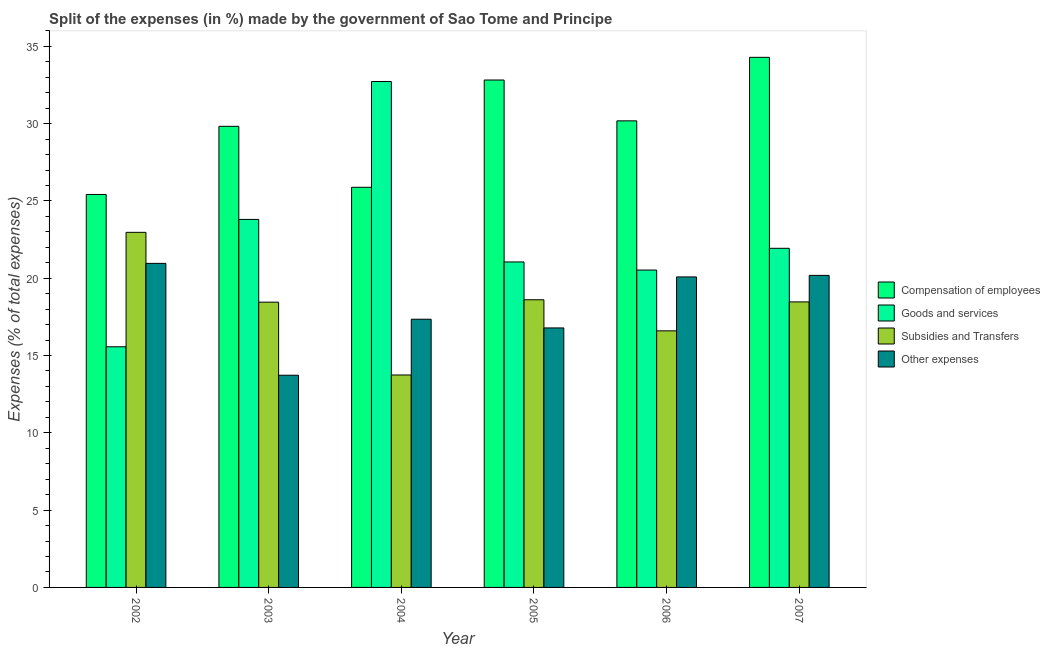How many different coloured bars are there?
Offer a terse response. 4. How many groups of bars are there?
Your answer should be very brief. 6. How many bars are there on the 2nd tick from the left?
Your answer should be compact. 4. How many bars are there on the 2nd tick from the right?
Provide a short and direct response. 4. What is the percentage of amount spent on goods and services in 2003?
Offer a terse response. 23.81. Across all years, what is the maximum percentage of amount spent on goods and services?
Offer a very short reply. 32.73. Across all years, what is the minimum percentage of amount spent on compensation of employees?
Provide a succinct answer. 25.42. In which year was the percentage of amount spent on subsidies maximum?
Make the answer very short. 2002. What is the total percentage of amount spent on other expenses in the graph?
Keep it short and to the point. 109.09. What is the difference between the percentage of amount spent on subsidies in 2002 and that in 2006?
Provide a short and direct response. 6.37. What is the difference between the percentage of amount spent on other expenses in 2004 and the percentage of amount spent on subsidies in 2002?
Keep it short and to the point. -3.61. What is the average percentage of amount spent on subsidies per year?
Offer a very short reply. 18.14. What is the ratio of the percentage of amount spent on compensation of employees in 2006 to that in 2007?
Your response must be concise. 0.88. Is the percentage of amount spent on subsidies in 2003 less than that in 2004?
Offer a terse response. No. Is the difference between the percentage of amount spent on subsidies in 2003 and 2007 greater than the difference between the percentage of amount spent on other expenses in 2003 and 2007?
Your response must be concise. No. What is the difference between the highest and the second highest percentage of amount spent on goods and services?
Your answer should be very brief. 8.92. What is the difference between the highest and the lowest percentage of amount spent on other expenses?
Give a very brief answer. 7.24. Is the sum of the percentage of amount spent on goods and services in 2002 and 2004 greater than the maximum percentage of amount spent on subsidies across all years?
Your answer should be very brief. Yes. Is it the case that in every year, the sum of the percentage of amount spent on subsidies and percentage of amount spent on goods and services is greater than the sum of percentage of amount spent on other expenses and percentage of amount spent on compensation of employees?
Give a very brief answer. No. What does the 1st bar from the left in 2004 represents?
Give a very brief answer. Compensation of employees. What does the 4th bar from the right in 2002 represents?
Your answer should be very brief. Compensation of employees. Is it the case that in every year, the sum of the percentage of amount spent on compensation of employees and percentage of amount spent on goods and services is greater than the percentage of amount spent on subsidies?
Make the answer very short. Yes. How many bars are there?
Make the answer very short. 24. How many years are there in the graph?
Provide a short and direct response. 6. What is the difference between two consecutive major ticks on the Y-axis?
Ensure brevity in your answer.  5. Are the values on the major ticks of Y-axis written in scientific E-notation?
Provide a short and direct response. No. Where does the legend appear in the graph?
Ensure brevity in your answer.  Center right. What is the title of the graph?
Give a very brief answer. Split of the expenses (in %) made by the government of Sao Tome and Principe. Does "Others" appear as one of the legend labels in the graph?
Ensure brevity in your answer.  No. What is the label or title of the Y-axis?
Give a very brief answer. Expenses (% of total expenses). What is the Expenses (% of total expenses) of Compensation of employees in 2002?
Offer a very short reply. 25.42. What is the Expenses (% of total expenses) in Goods and services in 2002?
Your answer should be very brief. 15.57. What is the Expenses (% of total expenses) in Subsidies and Transfers in 2002?
Ensure brevity in your answer.  22.97. What is the Expenses (% of total expenses) of Other expenses in 2002?
Give a very brief answer. 20.96. What is the Expenses (% of total expenses) of Compensation of employees in 2003?
Make the answer very short. 29.83. What is the Expenses (% of total expenses) in Goods and services in 2003?
Provide a short and direct response. 23.81. What is the Expenses (% of total expenses) in Subsidies and Transfers in 2003?
Your answer should be very brief. 18.45. What is the Expenses (% of total expenses) of Other expenses in 2003?
Offer a terse response. 13.73. What is the Expenses (% of total expenses) of Compensation of employees in 2004?
Provide a succinct answer. 25.88. What is the Expenses (% of total expenses) in Goods and services in 2004?
Provide a short and direct response. 32.73. What is the Expenses (% of total expenses) in Subsidies and Transfers in 2004?
Your answer should be very brief. 13.74. What is the Expenses (% of total expenses) of Other expenses in 2004?
Make the answer very short. 17.35. What is the Expenses (% of total expenses) in Compensation of employees in 2005?
Offer a very short reply. 32.82. What is the Expenses (% of total expenses) in Goods and services in 2005?
Keep it short and to the point. 21.05. What is the Expenses (% of total expenses) in Subsidies and Transfers in 2005?
Offer a terse response. 18.61. What is the Expenses (% of total expenses) of Other expenses in 2005?
Give a very brief answer. 16.79. What is the Expenses (% of total expenses) of Compensation of employees in 2006?
Provide a succinct answer. 30.18. What is the Expenses (% of total expenses) in Goods and services in 2006?
Ensure brevity in your answer.  20.53. What is the Expenses (% of total expenses) in Subsidies and Transfers in 2006?
Give a very brief answer. 16.6. What is the Expenses (% of total expenses) in Other expenses in 2006?
Offer a very short reply. 20.09. What is the Expenses (% of total expenses) in Compensation of employees in 2007?
Offer a terse response. 34.29. What is the Expenses (% of total expenses) of Goods and services in 2007?
Give a very brief answer. 21.94. What is the Expenses (% of total expenses) in Subsidies and Transfers in 2007?
Give a very brief answer. 18.47. What is the Expenses (% of total expenses) of Other expenses in 2007?
Make the answer very short. 20.19. Across all years, what is the maximum Expenses (% of total expenses) in Compensation of employees?
Provide a short and direct response. 34.29. Across all years, what is the maximum Expenses (% of total expenses) in Goods and services?
Keep it short and to the point. 32.73. Across all years, what is the maximum Expenses (% of total expenses) in Subsidies and Transfers?
Your answer should be very brief. 22.97. Across all years, what is the maximum Expenses (% of total expenses) in Other expenses?
Your response must be concise. 20.96. Across all years, what is the minimum Expenses (% of total expenses) of Compensation of employees?
Provide a short and direct response. 25.42. Across all years, what is the minimum Expenses (% of total expenses) of Goods and services?
Offer a terse response. 15.57. Across all years, what is the minimum Expenses (% of total expenses) in Subsidies and Transfers?
Offer a very short reply. 13.74. Across all years, what is the minimum Expenses (% of total expenses) in Other expenses?
Your answer should be very brief. 13.73. What is the total Expenses (% of total expenses) in Compensation of employees in the graph?
Your answer should be compact. 178.43. What is the total Expenses (% of total expenses) in Goods and services in the graph?
Your answer should be compact. 135.62. What is the total Expenses (% of total expenses) of Subsidies and Transfers in the graph?
Offer a terse response. 108.84. What is the total Expenses (% of total expenses) of Other expenses in the graph?
Make the answer very short. 109.09. What is the difference between the Expenses (% of total expenses) in Compensation of employees in 2002 and that in 2003?
Your response must be concise. -4.41. What is the difference between the Expenses (% of total expenses) of Goods and services in 2002 and that in 2003?
Provide a short and direct response. -8.24. What is the difference between the Expenses (% of total expenses) in Subsidies and Transfers in 2002 and that in 2003?
Keep it short and to the point. 4.52. What is the difference between the Expenses (% of total expenses) in Other expenses in 2002 and that in 2003?
Your response must be concise. 7.24. What is the difference between the Expenses (% of total expenses) in Compensation of employees in 2002 and that in 2004?
Give a very brief answer. -0.46. What is the difference between the Expenses (% of total expenses) of Goods and services in 2002 and that in 2004?
Keep it short and to the point. -17.16. What is the difference between the Expenses (% of total expenses) of Subsidies and Transfers in 2002 and that in 2004?
Offer a terse response. 9.23. What is the difference between the Expenses (% of total expenses) of Other expenses in 2002 and that in 2004?
Your response must be concise. 3.61. What is the difference between the Expenses (% of total expenses) of Compensation of employees in 2002 and that in 2005?
Provide a short and direct response. -7.4. What is the difference between the Expenses (% of total expenses) in Goods and services in 2002 and that in 2005?
Your answer should be very brief. -5.49. What is the difference between the Expenses (% of total expenses) in Subsidies and Transfers in 2002 and that in 2005?
Make the answer very short. 4.36. What is the difference between the Expenses (% of total expenses) in Other expenses in 2002 and that in 2005?
Keep it short and to the point. 4.18. What is the difference between the Expenses (% of total expenses) of Compensation of employees in 2002 and that in 2006?
Your response must be concise. -4.76. What is the difference between the Expenses (% of total expenses) of Goods and services in 2002 and that in 2006?
Ensure brevity in your answer.  -4.96. What is the difference between the Expenses (% of total expenses) in Subsidies and Transfers in 2002 and that in 2006?
Ensure brevity in your answer.  6.37. What is the difference between the Expenses (% of total expenses) in Other expenses in 2002 and that in 2006?
Keep it short and to the point. 0.88. What is the difference between the Expenses (% of total expenses) in Compensation of employees in 2002 and that in 2007?
Make the answer very short. -8.87. What is the difference between the Expenses (% of total expenses) of Goods and services in 2002 and that in 2007?
Ensure brevity in your answer.  -6.37. What is the difference between the Expenses (% of total expenses) of Subsidies and Transfers in 2002 and that in 2007?
Keep it short and to the point. 4.5. What is the difference between the Expenses (% of total expenses) in Other expenses in 2002 and that in 2007?
Provide a succinct answer. 0.78. What is the difference between the Expenses (% of total expenses) in Compensation of employees in 2003 and that in 2004?
Provide a succinct answer. 3.94. What is the difference between the Expenses (% of total expenses) in Goods and services in 2003 and that in 2004?
Offer a terse response. -8.92. What is the difference between the Expenses (% of total expenses) of Subsidies and Transfers in 2003 and that in 2004?
Keep it short and to the point. 4.71. What is the difference between the Expenses (% of total expenses) in Other expenses in 2003 and that in 2004?
Give a very brief answer. -3.62. What is the difference between the Expenses (% of total expenses) in Compensation of employees in 2003 and that in 2005?
Give a very brief answer. -3. What is the difference between the Expenses (% of total expenses) in Goods and services in 2003 and that in 2005?
Provide a succinct answer. 2.75. What is the difference between the Expenses (% of total expenses) in Subsidies and Transfers in 2003 and that in 2005?
Provide a short and direct response. -0.16. What is the difference between the Expenses (% of total expenses) in Other expenses in 2003 and that in 2005?
Provide a short and direct response. -3.06. What is the difference between the Expenses (% of total expenses) of Compensation of employees in 2003 and that in 2006?
Your response must be concise. -0.35. What is the difference between the Expenses (% of total expenses) in Goods and services in 2003 and that in 2006?
Offer a very short reply. 3.28. What is the difference between the Expenses (% of total expenses) of Subsidies and Transfers in 2003 and that in 2006?
Offer a terse response. 1.86. What is the difference between the Expenses (% of total expenses) in Other expenses in 2003 and that in 2006?
Give a very brief answer. -6.36. What is the difference between the Expenses (% of total expenses) of Compensation of employees in 2003 and that in 2007?
Offer a very short reply. -4.46. What is the difference between the Expenses (% of total expenses) of Goods and services in 2003 and that in 2007?
Keep it short and to the point. 1.87. What is the difference between the Expenses (% of total expenses) in Subsidies and Transfers in 2003 and that in 2007?
Make the answer very short. -0.02. What is the difference between the Expenses (% of total expenses) of Other expenses in 2003 and that in 2007?
Offer a very short reply. -6.46. What is the difference between the Expenses (% of total expenses) of Compensation of employees in 2004 and that in 2005?
Your answer should be very brief. -6.94. What is the difference between the Expenses (% of total expenses) in Goods and services in 2004 and that in 2005?
Keep it short and to the point. 11.67. What is the difference between the Expenses (% of total expenses) in Subsidies and Transfers in 2004 and that in 2005?
Make the answer very short. -4.87. What is the difference between the Expenses (% of total expenses) in Other expenses in 2004 and that in 2005?
Your answer should be very brief. 0.56. What is the difference between the Expenses (% of total expenses) in Compensation of employees in 2004 and that in 2006?
Your answer should be compact. -4.3. What is the difference between the Expenses (% of total expenses) in Goods and services in 2004 and that in 2006?
Your answer should be very brief. 12.2. What is the difference between the Expenses (% of total expenses) in Subsidies and Transfers in 2004 and that in 2006?
Your response must be concise. -2.85. What is the difference between the Expenses (% of total expenses) in Other expenses in 2004 and that in 2006?
Ensure brevity in your answer.  -2.74. What is the difference between the Expenses (% of total expenses) of Compensation of employees in 2004 and that in 2007?
Offer a very short reply. -8.41. What is the difference between the Expenses (% of total expenses) in Goods and services in 2004 and that in 2007?
Offer a very short reply. 10.79. What is the difference between the Expenses (% of total expenses) of Subsidies and Transfers in 2004 and that in 2007?
Your answer should be compact. -4.73. What is the difference between the Expenses (% of total expenses) in Other expenses in 2004 and that in 2007?
Offer a terse response. -2.84. What is the difference between the Expenses (% of total expenses) in Compensation of employees in 2005 and that in 2006?
Offer a very short reply. 2.64. What is the difference between the Expenses (% of total expenses) of Goods and services in 2005 and that in 2006?
Provide a succinct answer. 0.52. What is the difference between the Expenses (% of total expenses) of Subsidies and Transfers in 2005 and that in 2006?
Your response must be concise. 2.01. What is the difference between the Expenses (% of total expenses) of Other expenses in 2005 and that in 2006?
Ensure brevity in your answer.  -3.3. What is the difference between the Expenses (% of total expenses) of Compensation of employees in 2005 and that in 2007?
Provide a succinct answer. -1.47. What is the difference between the Expenses (% of total expenses) in Goods and services in 2005 and that in 2007?
Offer a very short reply. -0.88. What is the difference between the Expenses (% of total expenses) of Subsidies and Transfers in 2005 and that in 2007?
Make the answer very short. 0.14. What is the difference between the Expenses (% of total expenses) in Other expenses in 2005 and that in 2007?
Provide a succinct answer. -3.4. What is the difference between the Expenses (% of total expenses) of Compensation of employees in 2006 and that in 2007?
Offer a very short reply. -4.11. What is the difference between the Expenses (% of total expenses) of Goods and services in 2006 and that in 2007?
Your answer should be very brief. -1.41. What is the difference between the Expenses (% of total expenses) in Subsidies and Transfers in 2006 and that in 2007?
Give a very brief answer. -1.87. What is the difference between the Expenses (% of total expenses) of Other expenses in 2006 and that in 2007?
Your response must be concise. -0.1. What is the difference between the Expenses (% of total expenses) in Compensation of employees in 2002 and the Expenses (% of total expenses) in Goods and services in 2003?
Your answer should be compact. 1.61. What is the difference between the Expenses (% of total expenses) of Compensation of employees in 2002 and the Expenses (% of total expenses) of Subsidies and Transfers in 2003?
Offer a terse response. 6.97. What is the difference between the Expenses (% of total expenses) in Compensation of employees in 2002 and the Expenses (% of total expenses) in Other expenses in 2003?
Your answer should be very brief. 11.69. What is the difference between the Expenses (% of total expenses) in Goods and services in 2002 and the Expenses (% of total expenses) in Subsidies and Transfers in 2003?
Offer a terse response. -2.89. What is the difference between the Expenses (% of total expenses) in Goods and services in 2002 and the Expenses (% of total expenses) in Other expenses in 2003?
Offer a very short reply. 1.84. What is the difference between the Expenses (% of total expenses) of Subsidies and Transfers in 2002 and the Expenses (% of total expenses) of Other expenses in 2003?
Offer a very short reply. 9.24. What is the difference between the Expenses (% of total expenses) in Compensation of employees in 2002 and the Expenses (% of total expenses) in Goods and services in 2004?
Make the answer very short. -7.31. What is the difference between the Expenses (% of total expenses) in Compensation of employees in 2002 and the Expenses (% of total expenses) in Subsidies and Transfers in 2004?
Provide a succinct answer. 11.68. What is the difference between the Expenses (% of total expenses) of Compensation of employees in 2002 and the Expenses (% of total expenses) of Other expenses in 2004?
Offer a very short reply. 8.07. What is the difference between the Expenses (% of total expenses) of Goods and services in 2002 and the Expenses (% of total expenses) of Subsidies and Transfers in 2004?
Make the answer very short. 1.82. What is the difference between the Expenses (% of total expenses) in Goods and services in 2002 and the Expenses (% of total expenses) in Other expenses in 2004?
Provide a short and direct response. -1.78. What is the difference between the Expenses (% of total expenses) in Subsidies and Transfers in 2002 and the Expenses (% of total expenses) in Other expenses in 2004?
Provide a short and direct response. 5.62. What is the difference between the Expenses (% of total expenses) in Compensation of employees in 2002 and the Expenses (% of total expenses) in Goods and services in 2005?
Give a very brief answer. 4.37. What is the difference between the Expenses (% of total expenses) in Compensation of employees in 2002 and the Expenses (% of total expenses) in Subsidies and Transfers in 2005?
Keep it short and to the point. 6.81. What is the difference between the Expenses (% of total expenses) in Compensation of employees in 2002 and the Expenses (% of total expenses) in Other expenses in 2005?
Offer a very short reply. 8.63. What is the difference between the Expenses (% of total expenses) in Goods and services in 2002 and the Expenses (% of total expenses) in Subsidies and Transfers in 2005?
Your answer should be compact. -3.04. What is the difference between the Expenses (% of total expenses) in Goods and services in 2002 and the Expenses (% of total expenses) in Other expenses in 2005?
Make the answer very short. -1.22. What is the difference between the Expenses (% of total expenses) in Subsidies and Transfers in 2002 and the Expenses (% of total expenses) in Other expenses in 2005?
Give a very brief answer. 6.18. What is the difference between the Expenses (% of total expenses) of Compensation of employees in 2002 and the Expenses (% of total expenses) of Goods and services in 2006?
Your answer should be very brief. 4.89. What is the difference between the Expenses (% of total expenses) of Compensation of employees in 2002 and the Expenses (% of total expenses) of Subsidies and Transfers in 2006?
Your answer should be compact. 8.82. What is the difference between the Expenses (% of total expenses) of Compensation of employees in 2002 and the Expenses (% of total expenses) of Other expenses in 2006?
Provide a short and direct response. 5.33. What is the difference between the Expenses (% of total expenses) in Goods and services in 2002 and the Expenses (% of total expenses) in Subsidies and Transfers in 2006?
Make the answer very short. -1.03. What is the difference between the Expenses (% of total expenses) in Goods and services in 2002 and the Expenses (% of total expenses) in Other expenses in 2006?
Keep it short and to the point. -4.52. What is the difference between the Expenses (% of total expenses) of Subsidies and Transfers in 2002 and the Expenses (% of total expenses) of Other expenses in 2006?
Keep it short and to the point. 2.88. What is the difference between the Expenses (% of total expenses) in Compensation of employees in 2002 and the Expenses (% of total expenses) in Goods and services in 2007?
Make the answer very short. 3.48. What is the difference between the Expenses (% of total expenses) in Compensation of employees in 2002 and the Expenses (% of total expenses) in Subsidies and Transfers in 2007?
Your answer should be compact. 6.95. What is the difference between the Expenses (% of total expenses) in Compensation of employees in 2002 and the Expenses (% of total expenses) in Other expenses in 2007?
Offer a terse response. 5.23. What is the difference between the Expenses (% of total expenses) in Goods and services in 2002 and the Expenses (% of total expenses) in Subsidies and Transfers in 2007?
Give a very brief answer. -2.9. What is the difference between the Expenses (% of total expenses) of Goods and services in 2002 and the Expenses (% of total expenses) of Other expenses in 2007?
Give a very brief answer. -4.62. What is the difference between the Expenses (% of total expenses) in Subsidies and Transfers in 2002 and the Expenses (% of total expenses) in Other expenses in 2007?
Your answer should be very brief. 2.78. What is the difference between the Expenses (% of total expenses) in Compensation of employees in 2003 and the Expenses (% of total expenses) in Goods and services in 2004?
Give a very brief answer. -2.9. What is the difference between the Expenses (% of total expenses) of Compensation of employees in 2003 and the Expenses (% of total expenses) of Subsidies and Transfers in 2004?
Ensure brevity in your answer.  16.09. What is the difference between the Expenses (% of total expenses) of Compensation of employees in 2003 and the Expenses (% of total expenses) of Other expenses in 2004?
Make the answer very short. 12.48. What is the difference between the Expenses (% of total expenses) of Goods and services in 2003 and the Expenses (% of total expenses) of Subsidies and Transfers in 2004?
Ensure brevity in your answer.  10.06. What is the difference between the Expenses (% of total expenses) of Goods and services in 2003 and the Expenses (% of total expenses) of Other expenses in 2004?
Keep it short and to the point. 6.46. What is the difference between the Expenses (% of total expenses) in Subsidies and Transfers in 2003 and the Expenses (% of total expenses) in Other expenses in 2004?
Your response must be concise. 1.1. What is the difference between the Expenses (% of total expenses) of Compensation of employees in 2003 and the Expenses (% of total expenses) of Goods and services in 2005?
Provide a succinct answer. 8.77. What is the difference between the Expenses (% of total expenses) in Compensation of employees in 2003 and the Expenses (% of total expenses) in Subsidies and Transfers in 2005?
Your answer should be compact. 11.22. What is the difference between the Expenses (% of total expenses) in Compensation of employees in 2003 and the Expenses (% of total expenses) in Other expenses in 2005?
Keep it short and to the point. 13.04. What is the difference between the Expenses (% of total expenses) of Goods and services in 2003 and the Expenses (% of total expenses) of Subsidies and Transfers in 2005?
Keep it short and to the point. 5.2. What is the difference between the Expenses (% of total expenses) of Goods and services in 2003 and the Expenses (% of total expenses) of Other expenses in 2005?
Offer a terse response. 7.02. What is the difference between the Expenses (% of total expenses) of Subsidies and Transfers in 2003 and the Expenses (% of total expenses) of Other expenses in 2005?
Offer a terse response. 1.67. What is the difference between the Expenses (% of total expenses) of Compensation of employees in 2003 and the Expenses (% of total expenses) of Goods and services in 2006?
Give a very brief answer. 9.3. What is the difference between the Expenses (% of total expenses) in Compensation of employees in 2003 and the Expenses (% of total expenses) in Subsidies and Transfers in 2006?
Make the answer very short. 13.23. What is the difference between the Expenses (% of total expenses) of Compensation of employees in 2003 and the Expenses (% of total expenses) of Other expenses in 2006?
Ensure brevity in your answer.  9.74. What is the difference between the Expenses (% of total expenses) of Goods and services in 2003 and the Expenses (% of total expenses) of Subsidies and Transfers in 2006?
Give a very brief answer. 7.21. What is the difference between the Expenses (% of total expenses) of Goods and services in 2003 and the Expenses (% of total expenses) of Other expenses in 2006?
Ensure brevity in your answer.  3.72. What is the difference between the Expenses (% of total expenses) in Subsidies and Transfers in 2003 and the Expenses (% of total expenses) in Other expenses in 2006?
Offer a terse response. -1.63. What is the difference between the Expenses (% of total expenses) of Compensation of employees in 2003 and the Expenses (% of total expenses) of Goods and services in 2007?
Offer a very short reply. 7.89. What is the difference between the Expenses (% of total expenses) in Compensation of employees in 2003 and the Expenses (% of total expenses) in Subsidies and Transfers in 2007?
Offer a terse response. 11.36. What is the difference between the Expenses (% of total expenses) of Compensation of employees in 2003 and the Expenses (% of total expenses) of Other expenses in 2007?
Provide a short and direct response. 9.64. What is the difference between the Expenses (% of total expenses) in Goods and services in 2003 and the Expenses (% of total expenses) in Subsidies and Transfers in 2007?
Give a very brief answer. 5.34. What is the difference between the Expenses (% of total expenses) in Goods and services in 2003 and the Expenses (% of total expenses) in Other expenses in 2007?
Make the answer very short. 3.62. What is the difference between the Expenses (% of total expenses) of Subsidies and Transfers in 2003 and the Expenses (% of total expenses) of Other expenses in 2007?
Your answer should be compact. -1.73. What is the difference between the Expenses (% of total expenses) in Compensation of employees in 2004 and the Expenses (% of total expenses) in Goods and services in 2005?
Offer a terse response. 4.83. What is the difference between the Expenses (% of total expenses) of Compensation of employees in 2004 and the Expenses (% of total expenses) of Subsidies and Transfers in 2005?
Your answer should be very brief. 7.28. What is the difference between the Expenses (% of total expenses) of Compensation of employees in 2004 and the Expenses (% of total expenses) of Other expenses in 2005?
Give a very brief answer. 9.1. What is the difference between the Expenses (% of total expenses) of Goods and services in 2004 and the Expenses (% of total expenses) of Subsidies and Transfers in 2005?
Your response must be concise. 14.12. What is the difference between the Expenses (% of total expenses) in Goods and services in 2004 and the Expenses (% of total expenses) in Other expenses in 2005?
Provide a short and direct response. 15.94. What is the difference between the Expenses (% of total expenses) of Subsidies and Transfers in 2004 and the Expenses (% of total expenses) of Other expenses in 2005?
Keep it short and to the point. -3.04. What is the difference between the Expenses (% of total expenses) of Compensation of employees in 2004 and the Expenses (% of total expenses) of Goods and services in 2006?
Offer a very short reply. 5.35. What is the difference between the Expenses (% of total expenses) in Compensation of employees in 2004 and the Expenses (% of total expenses) in Subsidies and Transfers in 2006?
Offer a terse response. 9.29. What is the difference between the Expenses (% of total expenses) of Compensation of employees in 2004 and the Expenses (% of total expenses) of Other expenses in 2006?
Provide a succinct answer. 5.8. What is the difference between the Expenses (% of total expenses) in Goods and services in 2004 and the Expenses (% of total expenses) in Subsidies and Transfers in 2006?
Ensure brevity in your answer.  16.13. What is the difference between the Expenses (% of total expenses) in Goods and services in 2004 and the Expenses (% of total expenses) in Other expenses in 2006?
Make the answer very short. 12.64. What is the difference between the Expenses (% of total expenses) in Subsidies and Transfers in 2004 and the Expenses (% of total expenses) in Other expenses in 2006?
Ensure brevity in your answer.  -6.34. What is the difference between the Expenses (% of total expenses) in Compensation of employees in 2004 and the Expenses (% of total expenses) in Goods and services in 2007?
Give a very brief answer. 3.95. What is the difference between the Expenses (% of total expenses) of Compensation of employees in 2004 and the Expenses (% of total expenses) of Subsidies and Transfers in 2007?
Ensure brevity in your answer.  7.41. What is the difference between the Expenses (% of total expenses) of Compensation of employees in 2004 and the Expenses (% of total expenses) of Other expenses in 2007?
Keep it short and to the point. 5.7. What is the difference between the Expenses (% of total expenses) in Goods and services in 2004 and the Expenses (% of total expenses) in Subsidies and Transfers in 2007?
Offer a terse response. 14.26. What is the difference between the Expenses (% of total expenses) in Goods and services in 2004 and the Expenses (% of total expenses) in Other expenses in 2007?
Offer a very short reply. 12.54. What is the difference between the Expenses (% of total expenses) of Subsidies and Transfers in 2004 and the Expenses (% of total expenses) of Other expenses in 2007?
Your response must be concise. -6.44. What is the difference between the Expenses (% of total expenses) of Compensation of employees in 2005 and the Expenses (% of total expenses) of Goods and services in 2006?
Your response must be concise. 12.29. What is the difference between the Expenses (% of total expenses) in Compensation of employees in 2005 and the Expenses (% of total expenses) in Subsidies and Transfers in 2006?
Keep it short and to the point. 16.23. What is the difference between the Expenses (% of total expenses) of Compensation of employees in 2005 and the Expenses (% of total expenses) of Other expenses in 2006?
Your answer should be compact. 12.74. What is the difference between the Expenses (% of total expenses) of Goods and services in 2005 and the Expenses (% of total expenses) of Subsidies and Transfers in 2006?
Offer a very short reply. 4.46. What is the difference between the Expenses (% of total expenses) in Goods and services in 2005 and the Expenses (% of total expenses) in Other expenses in 2006?
Your response must be concise. 0.97. What is the difference between the Expenses (% of total expenses) of Subsidies and Transfers in 2005 and the Expenses (% of total expenses) of Other expenses in 2006?
Keep it short and to the point. -1.48. What is the difference between the Expenses (% of total expenses) of Compensation of employees in 2005 and the Expenses (% of total expenses) of Goods and services in 2007?
Provide a succinct answer. 10.89. What is the difference between the Expenses (% of total expenses) of Compensation of employees in 2005 and the Expenses (% of total expenses) of Subsidies and Transfers in 2007?
Your response must be concise. 14.35. What is the difference between the Expenses (% of total expenses) of Compensation of employees in 2005 and the Expenses (% of total expenses) of Other expenses in 2007?
Make the answer very short. 12.64. What is the difference between the Expenses (% of total expenses) in Goods and services in 2005 and the Expenses (% of total expenses) in Subsidies and Transfers in 2007?
Provide a short and direct response. 2.58. What is the difference between the Expenses (% of total expenses) in Goods and services in 2005 and the Expenses (% of total expenses) in Other expenses in 2007?
Ensure brevity in your answer.  0.87. What is the difference between the Expenses (% of total expenses) in Subsidies and Transfers in 2005 and the Expenses (% of total expenses) in Other expenses in 2007?
Make the answer very short. -1.58. What is the difference between the Expenses (% of total expenses) of Compensation of employees in 2006 and the Expenses (% of total expenses) of Goods and services in 2007?
Your response must be concise. 8.24. What is the difference between the Expenses (% of total expenses) of Compensation of employees in 2006 and the Expenses (% of total expenses) of Subsidies and Transfers in 2007?
Your response must be concise. 11.71. What is the difference between the Expenses (% of total expenses) of Compensation of employees in 2006 and the Expenses (% of total expenses) of Other expenses in 2007?
Give a very brief answer. 10. What is the difference between the Expenses (% of total expenses) in Goods and services in 2006 and the Expenses (% of total expenses) in Subsidies and Transfers in 2007?
Offer a terse response. 2.06. What is the difference between the Expenses (% of total expenses) in Goods and services in 2006 and the Expenses (% of total expenses) in Other expenses in 2007?
Offer a terse response. 0.34. What is the difference between the Expenses (% of total expenses) of Subsidies and Transfers in 2006 and the Expenses (% of total expenses) of Other expenses in 2007?
Your response must be concise. -3.59. What is the average Expenses (% of total expenses) in Compensation of employees per year?
Make the answer very short. 29.74. What is the average Expenses (% of total expenses) of Goods and services per year?
Your answer should be very brief. 22.6. What is the average Expenses (% of total expenses) of Subsidies and Transfers per year?
Your answer should be compact. 18.14. What is the average Expenses (% of total expenses) in Other expenses per year?
Give a very brief answer. 18.18. In the year 2002, what is the difference between the Expenses (% of total expenses) of Compensation of employees and Expenses (% of total expenses) of Goods and services?
Your response must be concise. 9.85. In the year 2002, what is the difference between the Expenses (% of total expenses) in Compensation of employees and Expenses (% of total expenses) in Subsidies and Transfers?
Provide a short and direct response. 2.45. In the year 2002, what is the difference between the Expenses (% of total expenses) of Compensation of employees and Expenses (% of total expenses) of Other expenses?
Give a very brief answer. 4.46. In the year 2002, what is the difference between the Expenses (% of total expenses) of Goods and services and Expenses (% of total expenses) of Subsidies and Transfers?
Ensure brevity in your answer.  -7.4. In the year 2002, what is the difference between the Expenses (% of total expenses) of Goods and services and Expenses (% of total expenses) of Other expenses?
Your response must be concise. -5.39. In the year 2002, what is the difference between the Expenses (% of total expenses) of Subsidies and Transfers and Expenses (% of total expenses) of Other expenses?
Your answer should be very brief. 2.01. In the year 2003, what is the difference between the Expenses (% of total expenses) of Compensation of employees and Expenses (% of total expenses) of Goods and services?
Offer a terse response. 6.02. In the year 2003, what is the difference between the Expenses (% of total expenses) of Compensation of employees and Expenses (% of total expenses) of Subsidies and Transfers?
Make the answer very short. 11.38. In the year 2003, what is the difference between the Expenses (% of total expenses) in Compensation of employees and Expenses (% of total expenses) in Other expenses?
Give a very brief answer. 16.1. In the year 2003, what is the difference between the Expenses (% of total expenses) of Goods and services and Expenses (% of total expenses) of Subsidies and Transfers?
Offer a terse response. 5.35. In the year 2003, what is the difference between the Expenses (% of total expenses) of Goods and services and Expenses (% of total expenses) of Other expenses?
Offer a terse response. 10.08. In the year 2003, what is the difference between the Expenses (% of total expenses) in Subsidies and Transfers and Expenses (% of total expenses) in Other expenses?
Ensure brevity in your answer.  4.73. In the year 2004, what is the difference between the Expenses (% of total expenses) of Compensation of employees and Expenses (% of total expenses) of Goods and services?
Make the answer very short. -6.84. In the year 2004, what is the difference between the Expenses (% of total expenses) of Compensation of employees and Expenses (% of total expenses) of Subsidies and Transfers?
Keep it short and to the point. 12.14. In the year 2004, what is the difference between the Expenses (% of total expenses) of Compensation of employees and Expenses (% of total expenses) of Other expenses?
Ensure brevity in your answer.  8.54. In the year 2004, what is the difference between the Expenses (% of total expenses) in Goods and services and Expenses (% of total expenses) in Subsidies and Transfers?
Give a very brief answer. 18.98. In the year 2004, what is the difference between the Expenses (% of total expenses) of Goods and services and Expenses (% of total expenses) of Other expenses?
Offer a very short reply. 15.38. In the year 2004, what is the difference between the Expenses (% of total expenses) of Subsidies and Transfers and Expenses (% of total expenses) of Other expenses?
Offer a terse response. -3.61. In the year 2005, what is the difference between the Expenses (% of total expenses) of Compensation of employees and Expenses (% of total expenses) of Goods and services?
Make the answer very short. 11.77. In the year 2005, what is the difference between the Expenses (% of total expenses) of Compensation of employees and Expenses (% of total expenses) of Subsidies and Transfers?
Provide a succinct answer. 14.21. In the year 2005, what is the difference between the Expenses (% of total expenses) in Compensation of employees and Expenses (% of total expenses) in Other expenses?
Your response must be concise. 16.04. In the year 2005, what is the difference between the Expenses (% of total expenses) in Goods and services and Expenses (% of total expenses) in Subsidies and Transfers?
Your answer should be very brief. 2.45. In the year 2005, what is the difference between the Expenses (% of total expenses) of Goods and services and Expenses (% of total expenses) of Other expenses?
Ensure brevity in your answer.  4.27. In the year 2005, what is the difference between the Expenses (% of total expenses) of Subsidies and Transfers and Expenses (% of total expenses) of Other expenses?
Your answer should be compact. 1.82. In the year 2006, what is the difference between the Expenses (% of total expenses) in Compensation of employees and Expenses (% of total expenses) in Goods and services?
Give a very brief answer. 9.65. In the year 2006, what is the difference between the Expenses (% of total expenses) of Compensation of employees and Expenses (% of total expenses) of Subsidies and Transfers?
Provide a succinct answer. 13.58. In the year 2006, what is the difference between the Expenses (% of total expenses) of Compensation of employees and Expenses (% of total expenses) of Other expenses?
Your answer should be compact. 10.1. In the year 2006, what is the difference between the Expenses (% of total expenses) in Goods and services and Expenses (% of total expenses) in Subsidies and Transfers?
Your answer should be compact. 3.93. In the year 2006, what is the difference between the Expenses (% of total expenses) of Goods and services and Expenses (% of total expenses) of Other expenses?
Ensure brevity in your answer.  0.45. In the year 2006, what is the difference between the Expenses (% of total expenses) of Subsidies and Transfers and Expenses (% of total expenses) of Other expenses?
Your answer should be compact. -3.49. In the year 2007, what is the difference between the Expenses (% of total expenses) of Compensation of employees and Expenses (% of total expenses) of Goods and services?
Provide a succinct answer. 12.35. In the year 2007, what is the difference between the Expenses (% of total expenses) of Compensation of employees and Expenses (% of total expenses) of Subsidies and Transfers?
Your answer should be very brief. 15.82. In the year 2007, what is the difference between the Expenses (% of total expenses) of Compensation of employees and Expenses (% of total expenses) of Other expenses?
Your answer should be very brief. 14.11. In the year 2007, what is the difference between the Expenses (% of total expenses) in Goods and services and Expenses (% of total expenses) in Subsidies and Transfers?
Your response must be concise. 3.47. In the year 2007, what is the difference between the Expenses (% of total expenses) of Goods and services and Expenses (% of total expenses) of Other expenses?
Give a very brief answer. 1.75. In the year 2007, what is the difference between the Expenses (% of total expenses) in Subsidies and Transfers and Expenses (% of total expenses) in Other expenses?
Offer a very short reply. -1.72. What is the ratio of the Expenses (% of total expenses) in Compensation of employees in 2002 to that in 2003?
Your response must be concise. 0.85. What is the ratio of the Expenses (% of total expenses) in Goods and services in 2002 to that in 2003?
Your answer should be very brief. 0.65. What is the ratio of the Expenses (% of total expenses) in Subsidies and Transfers in 2002 to that in 2003?
Your response must be concise. 1.24. What is the ratio of the Expenses (% of total expenses) in Other expenses in 2002 to that in 2003?
Keep it short and to the point. 1.53. What is the ratio of the Expenses (% of total expenses) in Compensation of employees in 2002 to that in 2004?
Your answer should be very brief. 0.98. What is the ratio of the Expenses (% of total expenses) in Goods and services in 2002 to that in 2004?
Provide a succinct answer. 0.48. What is the ratio of the Expenses (% of total expenses) in Subsidies and Transfers in 2002 to that in 2004?
Your response must be concise. 1.67. What is the ratio of the Expenses (% of total expenses) of Other expenses in 2002 to that in 2004?
Make the answer very short. 1.21. What is the ratio of the Expenses (% of total expenses) in Compensation of employees in 2002 to that in 2005?
Offer a terse response. 0.77. What is the ratio of the Expenses (% of total expenses) in Goods and services in 2002 to that in 2005?
Give a very brief answer. 0.74. What is the ratio of the Expenses (% of total expenses) in Subsidies and Transfers in 2002 to that in 2005?
Make the answer very short. 1.23. What is the ratio of the Expenses (% of total expenses) of Other expenses in 2002 to that in 2005?
Ensure brevity in your answer.  1.25. What is the ratio of the Expenses (% of total expenses) in Compensation of employees in 2002 to that in 2006?
Provide a short and direct response. 0.84. What is the ratio of the Expenses (% of total expenses) of Goods and services in 2002 to that in 2006?
Offer a terse response. 0.76. What is the ratio of the Expenses (% of total expenses) of Subsidies and Transfers in 2002 to that in 2006?
Ensure brevity in your answer.  1.38. What is the ratio of the Expenses (% of total expenses) of Other expenses in 2002 to that in 2006?
Offer a very short reply. 1.04. What is the ratio of the Expenses (% of total expenses) of Compensation of employees in 2002 to that in 2007?
Keep it short and to the point. 0.74. What is the ratio of the Expenses (% of total expenses) in Goods and services in 2002 to that in 2007?
Offer a very short reply. 0.71. What is the ratio of the Expenses (% of total expenses) of Subsidies and Transfers in 2002 to that in 2007?
Offer a very short reply. 1.24. What is the ratio of the Expenses (% of total expenses) in Compensation of employees in 2003 to that in 2004?
Offer a terse response. 1.15. What is the ratio of the Expenses (% of total expenses) of Goods and services in 2003 to that in 2004?
Your answer should be very brief. 0.73. What is the ratio of the Expenses (% of total expenses) in Subsidies and Transfers in 2003 to that in 2004?
Offer a very short reply. 1.34. What is the ratio of the Expenses (% of total expenses) of Other expenses in 2003 to that in 2004?
Keep it short and to the point. 0.79. What is the ratio of the Expenses (% of total expenses) of Compensation of employees in 2003 to that in 2005?
Ensure brevity in your answer.  0.91. What is the ratio of the Expenses (% of total expenses) in Goods and services in 2003 to that in 2005?
Provide a succinct answer. 1.13. What is the ratio of the Expenses (% of total expenses) in Subsidies and Transfers in 2003 to that in 2005?
Your answer should be very brief. 0.99. What is the ratio of the Expenses (% of total expenses) of Other expenses in 2003 to that in 2005?
Your answer should be very brief. 0.82. What is the ratio of the Expenses (% of total expenses) of Compensation of employees in 2003 to that in 2006?
Make the answer very short. 0.99. What is the ratio of the Expenses (% of total expenses) of Goods and services in 2003 to that in 2006?
Your answer should be very brief. 1.16. What is the ratio of the Expenses (% of total expenses) in Subsidies and Transfers in 2003 to that in 2006?
Your response must be concise. 1.11. What is the ratio of the Expenses (% of total expenses) of Other expenses in 2003 to that in 2006?
Your response must be concise. 0.68. What is the ratio of the Expenses (% of total expenses) of Compensation of employees in 2003 to that in 2007?
Ensure brevity in your answer.  0.87. What is the ratio of the Expenses (% of total expenses) of Goods and services in 2003 to that in 2007?
Your response must be concise. 1.09. What is the ratio of the Expenses (% of total expenses) of Other expenses in 2003 to that in 2007?
Offer a terse response. 0.68. What is the ratio of the Expenses (% of total expenses) of Compensation of employees in 2004 to that in 2005?
Offer a terse response. 0.79. What is the ratio of the Expenses (% of total expenses) of Goods and services in 2004 to that in 2005?
Provide a short and direct response. 1.55. What is the ratio of the Expenses (% of total expenses) in Subsidies and Transfers in 2004 to that in 2005?
Your response must be concise. 0.74. What is the ratio of the Expenses (% of total expenses) in Other expenses in 2004 to that in 2005?
Offer a terse response. 1.03. What is the ratio of the Expenses (% of total expenses) in Compensation of employees in 2004 to that in 2006?
Provide a short and direct response. 0.86. What is the ratio of the Expenses (% of total expenses) of Goods and services in 2004 to that in 2006?
Your answer should be very brief. 1.59. What is the ratio of the Expenses (% of total expenses) in Subsidies and Transfers in 2004 to that in 2006?
Offer a very short reply. 0.83. What is the ratio of the Expenses (% of total expenses) in Other expenses in 2004 to that in 2006?
Keep it short and to the point. 0.86. What is the ratio of the Expenses (% of total expenses) in Compensation of employees in 2004 to that in 2007?
Provide a succinct answer. 0.75. What is the ratio of the Expenses (% of total expenses) of Goods and services in 2004 to that in 2007?
Your answer should be very brief. 1.49. What is the ratio of the Expenses (% of total expenses) in Subsidies and Transfers in 2004 to that in 2007?
Offer a very short reply. 0.74. What is the ratio of the Expenses (% of total expenses) of Other expenses in 2004 to that in 2007?
Give a very brief answer. 0.86. What is the ratio of the Expenses (% of total expenses) in Compensation of employees in 2005 to that in 2006?
Provide a short and direct response. 1.09. What is the ratio of the Expenses (% of total expenses) in Goods and services in 2005 to that in 2006?
Offer a terse response. 1.03. What is the ratio of the Expenses (% of total expenses) of Subsidies and Transfers in 2005 to that in 2006?
Ensure brevity in your answer.  1.12. What is the ratio of the Expenses (% of total expenses) in Other expenses in 2005 to that in 2006?
Offer a terse response. 0.84. What is the ratio of the Expenses (% of total expenses) of Compensation of employees in 2005 to that in 2007?
Make the answer very short. 0.96. What is the ratio of the Expenses (% of total expenses) in Goods and services in 2005 to that in 2007?
Make the answer very short. 0.96. What is the ratio of the Expenses (% of total expenses) in Subsidies and Transfers in 2005 to that in 2007?
Ensure brevity in your answer.  1.01. What is the ratio of the Expenses (% of total expenses) in Other expenses in 2005 to that in 2007?
Ensure brevity in your answer.  0.83. What is the ratio of the Expenses (% of total expenses) of Compensation of employees in 2006 to that in 2007?
Offer a very short reply. 0.88. What is the ratio of the Expenses (% of total expenses) of Goods and services in 2006 to that in 2007?
Provide a succinct answer. 0.94. What is the ratio of the Expenses (% of total expenses) of Subsidies and Transfers in 2006 to that in 2007?
Ensure brevity in your answer.  0.9. What is the difference between the highest and the second highest Expenses (% of total expenses) in Compensation of employees?
Ensure brevity in your answer.  1.47. What is the difference between the highest and the second highest Expenses (% of total expenses) of Goods and services?
Provide a succinct answer. 8.92. What is the difference between the highest and the second highest Expenses (% of total expenses) of Subsidies and Transfers?
Give a very brief answer. 4.36. What is the difference between the highest and the second highest Expenses (% of total expenses) in Other expenses?
Provide a short and direct response. 0.78. What is the difference between the highest and the lowest Expenses (% of total expenses) in Compensation of employees?
Give a very brief answer. 8.87. What is the difference between the highest and the lowest Expenses (% of total expenses) of Goods and services?
Your response must be concise. 17.16. What is the difference between the highest and the lowest Expenses (% of total expenses) of Subsidies and Transfers?
Keep it short and to the point. 9.23. What is the difference between the highest and the lowest Expenses (% of total expenses) in Other expenses?
Ensure brevity in your answer.  7.24. 